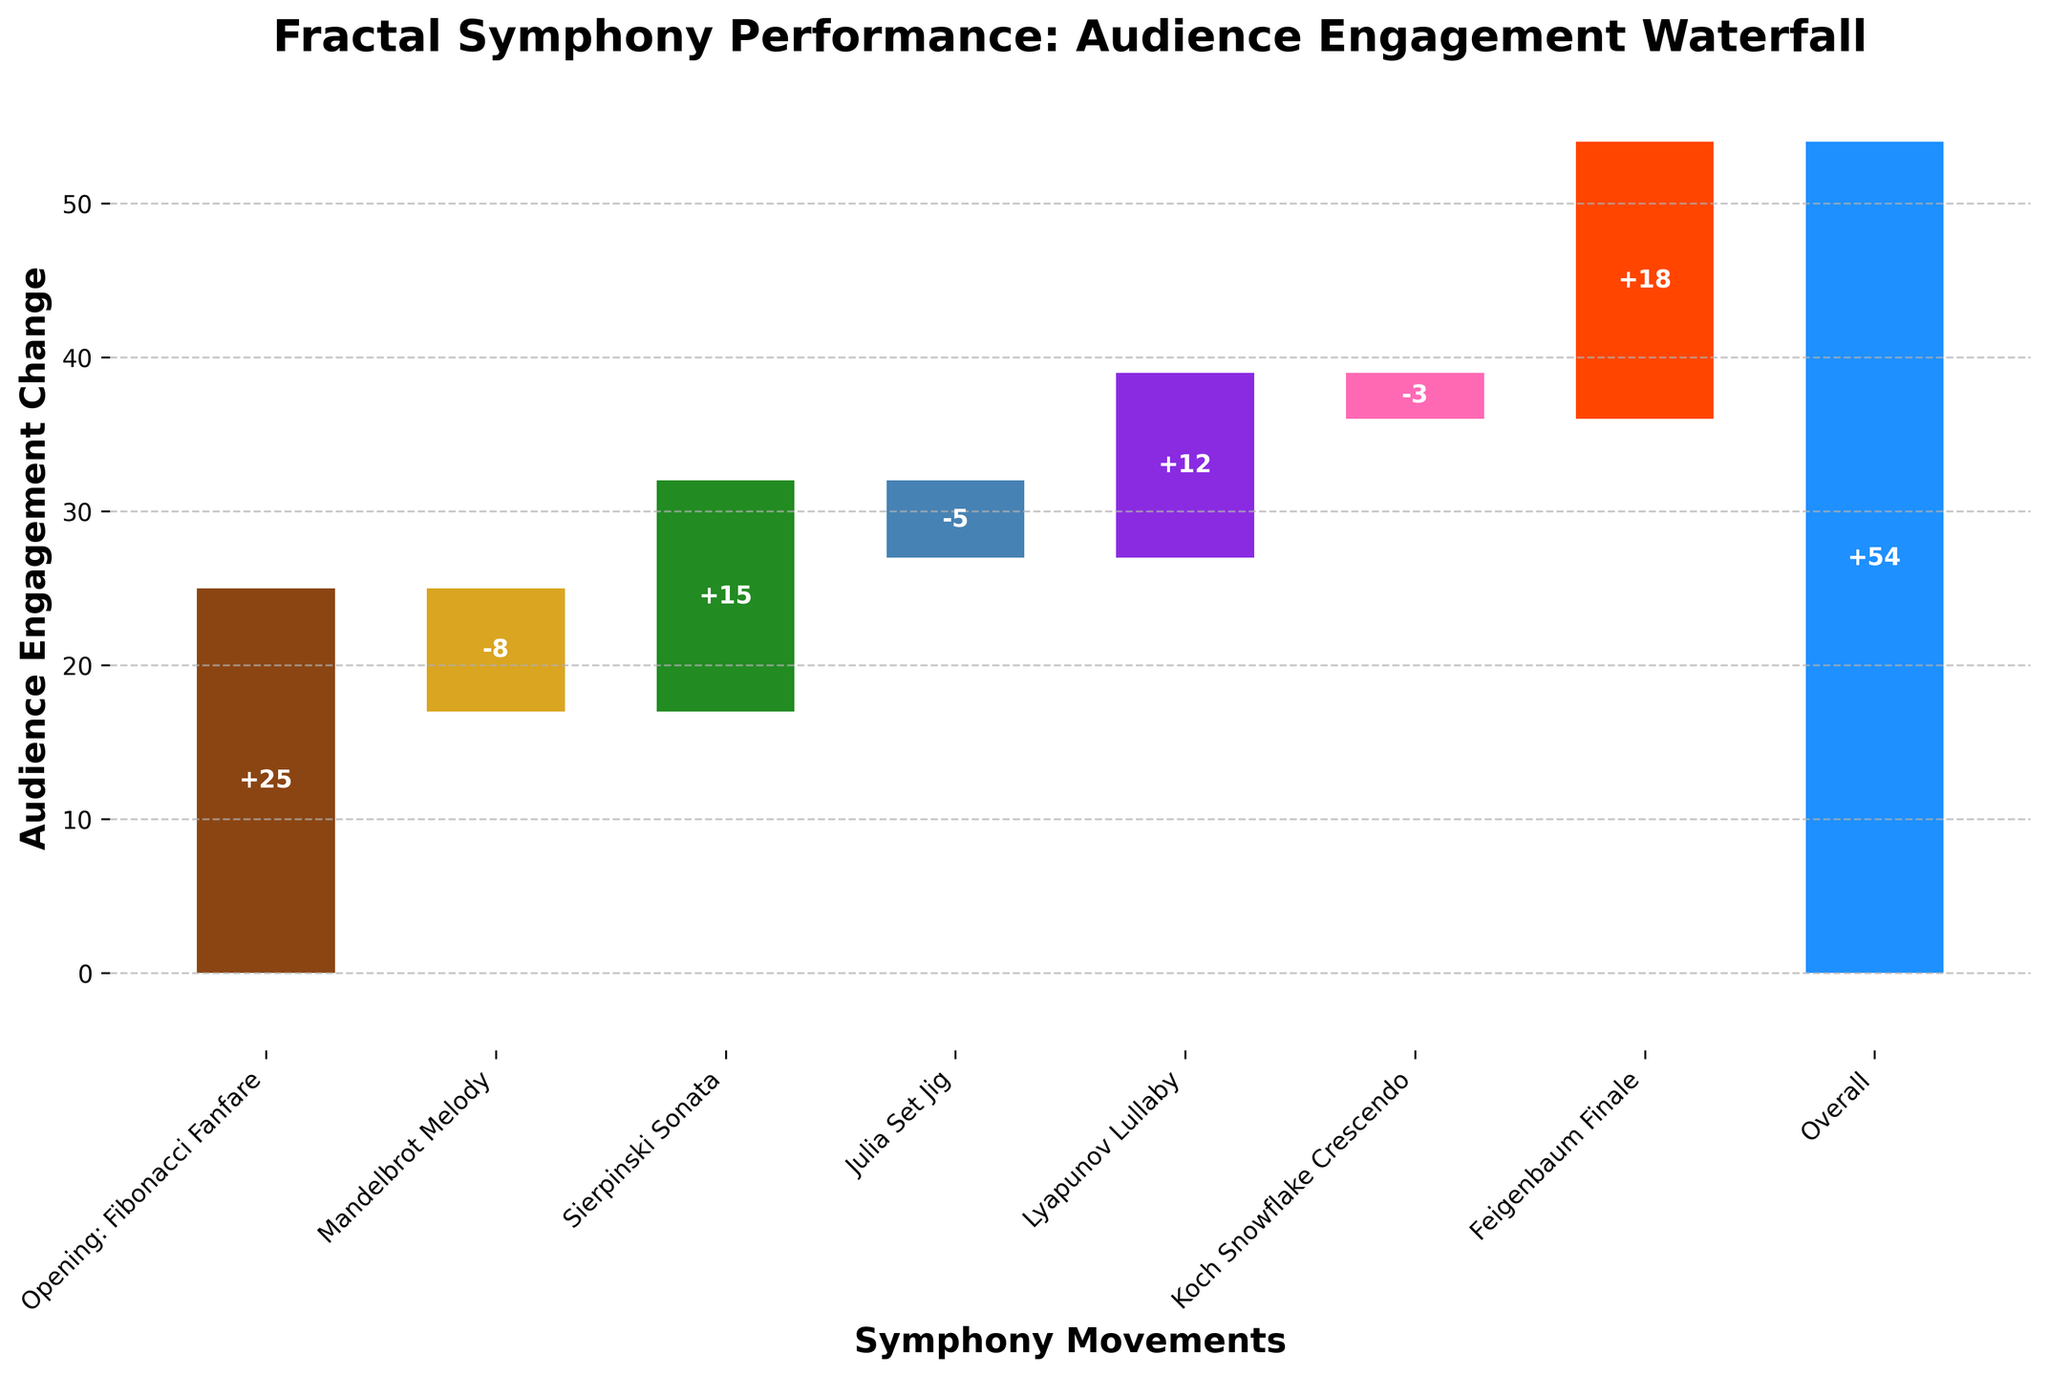What's the title of the figure? The title of the figure is generally at the top and clearly states the purpose of the visualization.
Answer: Fractal Symphony Performance: Audience Engagement Waterfall What movement shows the highest increase in audience engagement? By observing the height of the bars, the movement with the tallest positive bar indicates the highest increase in audience engagement.
Answer: Opening: Fibonacci Fanfare Which movements show a decrease in audience engagement? The bars that extend downward from the baseline or previous movement's cumulative engagement indicate a decrease in audience engagement.
Answer: Mandelbrot Melody, Julia Set Jig, Koch Snowflake Crescendo What's the overall audience engagement change for the performance? The overall engagement change is represented by the final bar labeled "Overall Performance," usually found at the end of the sequence.
Answer: +54 How much did the Sierpinski Sonata contribute to audience engagement change? Look for the height of the bar labeled "Sierpinski Sonata" and read the value indicated on or beside it.
Answer: +15 Which movement had the smallest negative impact on audience engagement? Comparing the negative bars, the shortest negative bar represents the smallest decrease in audience engagement.
Answer: Koch Snowflake Crescendo What's the combined engagement change for Mandelbrot Melody and Julia Set Jig? Sum the engagement changes of the two movements by adding their respective values. Mandelbrot Melody is -8 and Julia Set Jig is -5. So, -8 + (-5) = -13.
Answer: -13 What's the difference in audience engagement change between the Lyapunov Lullaby and Feigenbaum Finale? To find the difference, subtract the engagement change of Lyapunov Lullaby from Feigenbaum Finale. Feigenbaum Finale is +18 and Lyapunov Lullaby is +12. Therefore, 18 - 12 = 6.
Answer: 6 What is the cumulative change in audience engagement up to the Julia Set Jig? Sum the engagement changes for all movements up to and including Julia Set Jig. (+25) + (-8) + (+15) + (-5) = 27.
Answer: +27 Which two consecutive movements had the largest cumulative audience engagement gain? Find the pair of consecutive movements where the sum of their engagement changes is the highest. Here, we need to look at each consecutive pair and sum their values; e.g., Fibonacci Fanfare (+25) and Sierpinski Sonata (+15) gives +40.
Answer: Opening: Fibonacci Fanfare and Sierpinski Sonata 